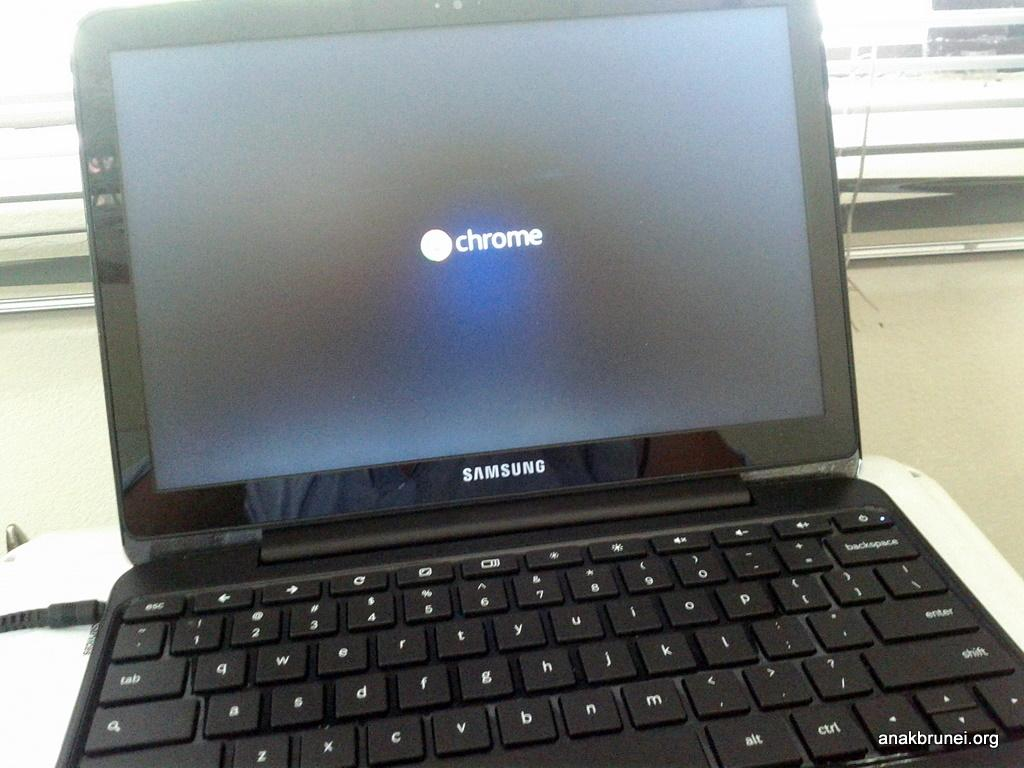<image>
Offer a succinct explanation of the picture presented. An open laptop with the word chrome on the screen 